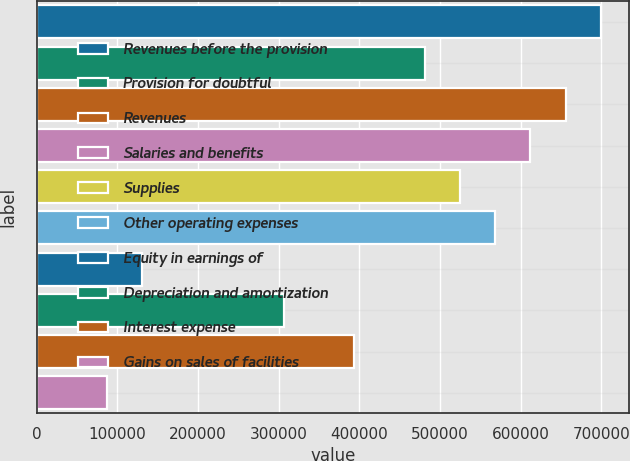Convert chart. <chart><loc_0><loc_0><loc_500><loc_500><bar_chart><fcel>Revenues before the provision<fcel>Provision for doubtful<fcel>Revenues<fcel>Salaries and benefits<fcel>Supplies<fcel>Other operating expenses<fcel>Equity in earnings of<fcel>Depreciation and amortization<fcel>Interest expense<fcel>Gains on sales of facilities<nl><fcel>699753<fcel>481081<fcel>656019<fcel>612285<fcel>524816<fcel>568550<fcel>131206<fcel>306144<fcel>393613<fcel>87471.6<nl></chart> 